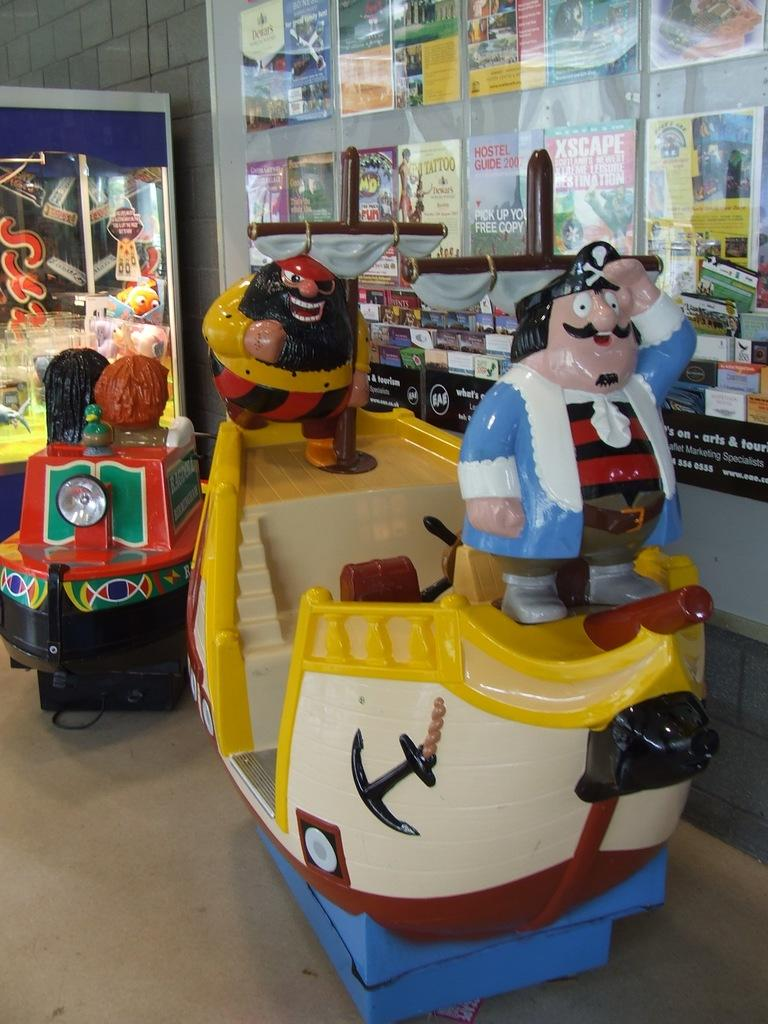<image>
Provide a brief description of the given image. A hostel guide from 2007 hangs on the wall near a toy ship for children. 